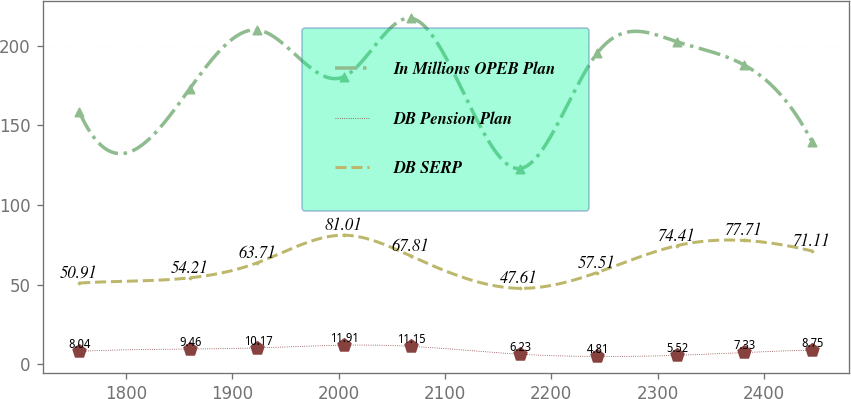<chart> <loc_0><loc_0><loc_500><loc_500><line_chart><ecel><fcel>In Millions OPEB Plan<fcel>DB Pension Plan<fcel>DB SERP<nl><fcel>1755.91<fcel>158.62<fcel>8.04<fcel>50.91<nl><fcel>1860.03<fcel>173.17<fcel>9.46<fcel>54.21<nl><fcel>1923.63<fcel>209.97<fcel>10.17<fcel>63.71<nl><fcel>2004.62<fcel>180.53<fcel>11.91<fcel>81.01<nl><fcel>2068.22<fcel>217.33<fcel>11.15<fcel>67.81<nl><fcel>2170.1<fcel>122.89<fcel>6.23<fcel>47.61<nl><fcel>2242.95<fcel>195.25<fcel>4.81<fcel>57.51<nl><fcel>2317.99<fcel>202.61<fcel>5.52<fcel>74.41<nl><fcel>2381.59<fcel>187.89<fcel>7.33<fcel>77.71<nl><fcel>2445.19<fcel>139.86<fcel>8.75<fcel>71.11<nl></chart> 